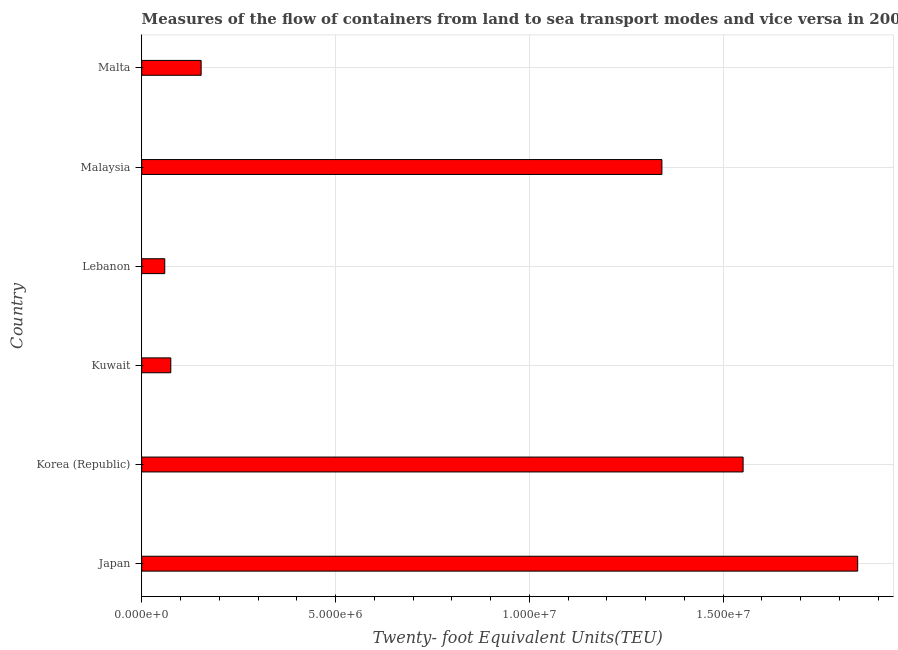Does the graph contain grids?
Provide a succinct answer. Yes. What is the title of the graph?
Make the answer very short. Measures of the flow of containers from land to sea transport modes and vice versa in 2006. What is the label or title of the X-axis?
Make the answer very short. Twenty- foot Equivalent Units(TEU). What is the container port traffic in Malaysia?
Your answer should be very brief. 1.34e+07. Across all countries, what is the maximum container port traffic?
Give a very brief answer. 1.85e+07. Across all countries, what is the minimum container port traffic?
Your answer should be very brief. 5.95e+05. In which country was the container port traffic minimum?
Your response must be concise. Lebanon. What is the sum of the container port traffic?
Ensure brevity in your answer.  5.03e+07. What is the difference between the container port traffic in Korea (Republic) and Malta?
Keep it short and to the point. 1.40e+07. What is the average container port traffic per country?
Offer a very short reply. 8.38e+06. What is the median container port traffic?
Provide a short and direct response. 7.48e+06. In how many countries, is the container port traffic greater than 2000000 TEU?
Ensure brevity in your answer.  3. What is the ratio of the container port traffic in Japan to that in Malta?
Offer a very short reply. 12.05. Is the container port traffic in Japan less than that in Lebanon?
Offer a terse response. No. Is the difference between the container port traffic in Japan and Malaysia greater than the difference between any two countries?
Keep it short and to the point. No. What is the difference between the highest and the second highest container port traffic?
Your answer should be very brief. 2.96e+06. Is the sum of the container port traffic in Lebanon and Malta greater than the maximum container port traffic across all countries?
Provide a short and direct response. No. What is the difference between the highest and the lowest container port traffic?
Your answer should be very brief. 1.79e+07. In how many countries, is the container port traffic greater than the average container port traffic taken over all countries?
Your response must be concise. 3. How many countries are there in the graph?
Your answer should be compact. 6. Are the values on the major ticks of X-axis written in scientific E-notation?
Your response must be concise. Yes. What is the Twenty- foot Equivalent Units(TEU) of Japan?
Provide a short and direct response. 1.85e+07. What is the Twenty- foot Equivalent Units(TEU) in Korea (Republic)?
Give a very brief answer. 1.55e+07. What is the Twenty- foot Equivalent Units(TEU) of Kuwait?
Make the answer very short. 7.50e+05. What is the Twenty- foot Equivalent Units(TEU) of Lebanon?
Make the answer very short. 5.95e+05. What is the Twenty- foot Equivalent Units(TEU) of Malaysia?
Give a very brief answer. 1.34e+07. What is the Twenty- foot Equivalent Units(TEU) in Malta?
Make the answer very short. 1.53e+06. What is the difference between the Twenty- foot Equivalent Units(TEU) in Japan and Korea (Republic)?
Make the answer very short. 2.96e+06. What is the difference between the Twenty- foot Equivalent Units(TEU) in Japan and Kuwait?
Your answer should be very brief. 1.77e+07. What is the difference between the Twenty- foot Equivalent Units(TEU) in Japan and Lebanon?
Give a very brief answer. 1.79e+07. What is the difference between the Twenty- foot Equivalent Units(TEU) in Japan and Malaysia?
Offer a terse response. 5.05e+06. What is the difference between the Twenty- foot Equivalent Units(TEU) in Japan and Malta?
Your response must be concise. 1.69e+07. What is the difference between the Twenty- foot Equivalent Units(TEU) in Korea (Republic) and Kuwait?
Provide a succinct answer. 1.48e+07. What is the difference between the Twenty- foot Equivalent Units(TEU) in Korea (Republic) and Lebanon?
Your response must be concise. 1.49e+07. What is the difference between the Twenty- foot Equivalent Units(TEU) in Korea (Republic) and Malaysia?
Offer a terse response. 2.09e+06. What is the difference between the Twenty- foot Equivalent Units(TEU) in Korea (Republic) and Malta?
Make the answer very short. 1.40e+07. What is the difference between the Twenty- foot Equivalent Units(TEU) in Kuwait and Lebanon?
Your answer should be very brief. 1.55e+05. What is the difference between the Twenty- foot Equivalent Units(TEU) in Kuwait and Malaysia?
Provide a succinct answer. -1.27e+07. What is the difference between the Twenty- foot Equivalent Units(TEU) in Kuwait and Malta?
Ensure brevity in your answer.  -7.83e+05. What is the difference between the Twenty- foot Equivalent Units(TEU) in Lebanon and Malaysia?
Offer a very short reply. -1.28e+07. What is the difference between the Twenty- foot Equivalent Units(TEU) in Lebanon and Malta?
Provide a short and direct response. -9.38e+05. What is the difference between the Twenty- foot Equivalent Units(TEU) in Malaysia and Malta?
Give a very brief answer. 1.19e+07. What is the ratio of the Twenty- foot Equivalent Units(TEU) in Japan to that in Korea (Republic)?
Provide a short and direct response. 1.19. What is the ratio of the Twenty- foot Equivalent Units(TEU) in Japan to that in Kuwait?
Offer a very short reply. 24.63. What is the ratio of the Twenty- foot Equivalent Units(TEU) in Japan to that in Lebanon?
Keep it short and to the point. 31.06. What is the ratio of the Twenty- foot Equivalent Units(TEU) in Japan to that in Malaysia?
Keep it short and to the point. 1.38. What is the ratio of the Twenty- foot Equivalent Units(TEU) in Japan to that in Malta?
Make the answer very short. 12.05. What is the ratio of the Twenty- foot Equivalent Units(TEU) in Korea (Republic) to that in Kuwait?
Provide a short and direct response. 20.68. What is the ratio of the Twenty- foot Equivalent Units(TEU) in Korea (Republic) to that in Lebanon?
Your answer should be very brief. 26.09. What is the ratio of the Twenty- foot Equivalent Units(TEU) in Korea (Republic) to that in Malaysia?
Offer a terse response. 1.16. What is the ratio of the Twenty- foot Equivalent Units(TEU) in Korea (Republic) to that in Malta?
Offer a terse response. 10.12. What is the ratio of the Twenty- foot Equivalent Units(TEU) in Kuwait to that in Lebanon?
Ensure brevity in your answer.  1.26. What is the ratio of the Twenty- foot Equivalent Units(TEU) in Kuwait to that in Malaysia?
Provide a short and direct response. 0.06. What is the ratio of the Twenty- foot Equivalent Units(TEU) in Kuwait to that in Malta?
Give a very brief answer. 0.49. What is the ratio of the Twenty- foot Equivalent Units(TEU) in Lebanon to that in Malaysia?
Offer a terse response. 0.04. What is the ratio of the Twenty- foot Equivalent Units(TEU) in Lebanon to that in Malta?
Offer a terse response. 0.39. What is the ratio of the Twenty- foot Equivalent Units(TEU) in Malaysia to that in Malta?
Your answer should be compact. 8.75. 